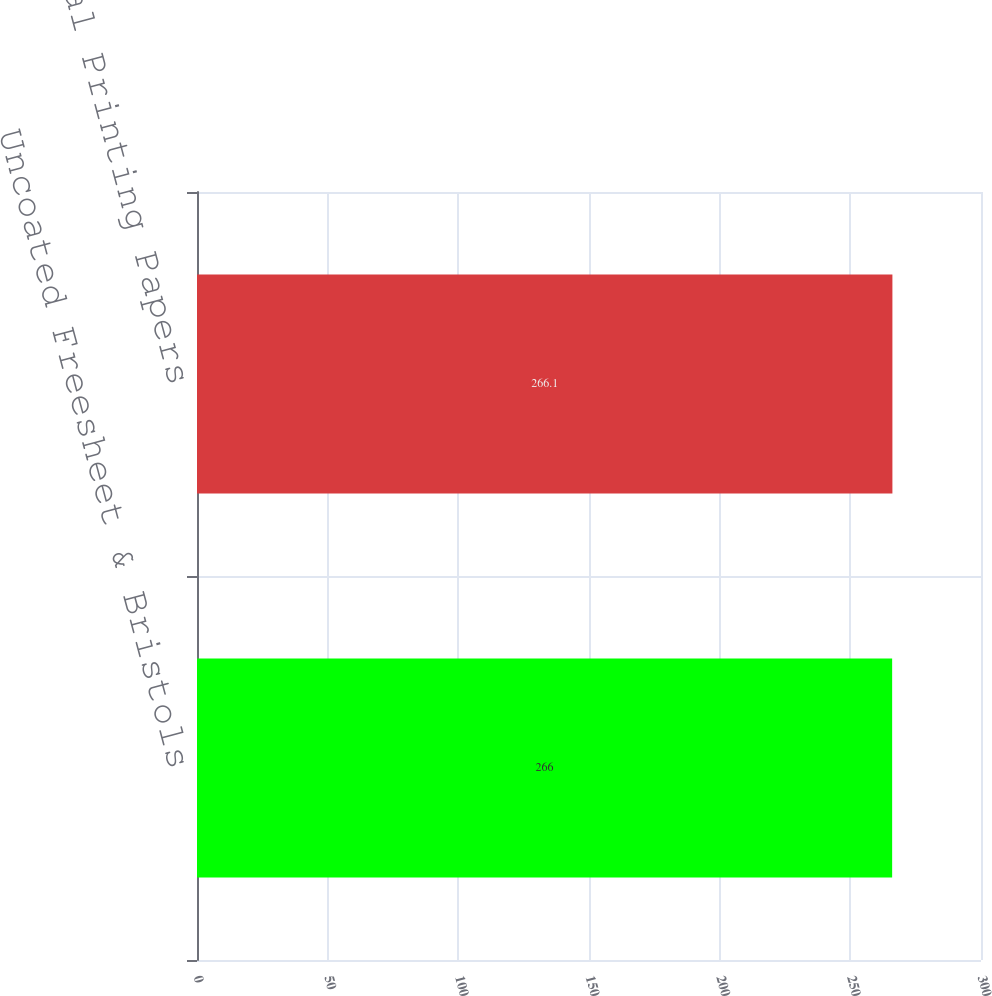Convert chart. <chart><loc_0><loc_0><loc_500><loc_500><bar_chart><fcel>Uncoated Freesheet & Bristols<fcel>Total Printing Papers<nl><fcel>266<fcel>266.1<nl></chart> 